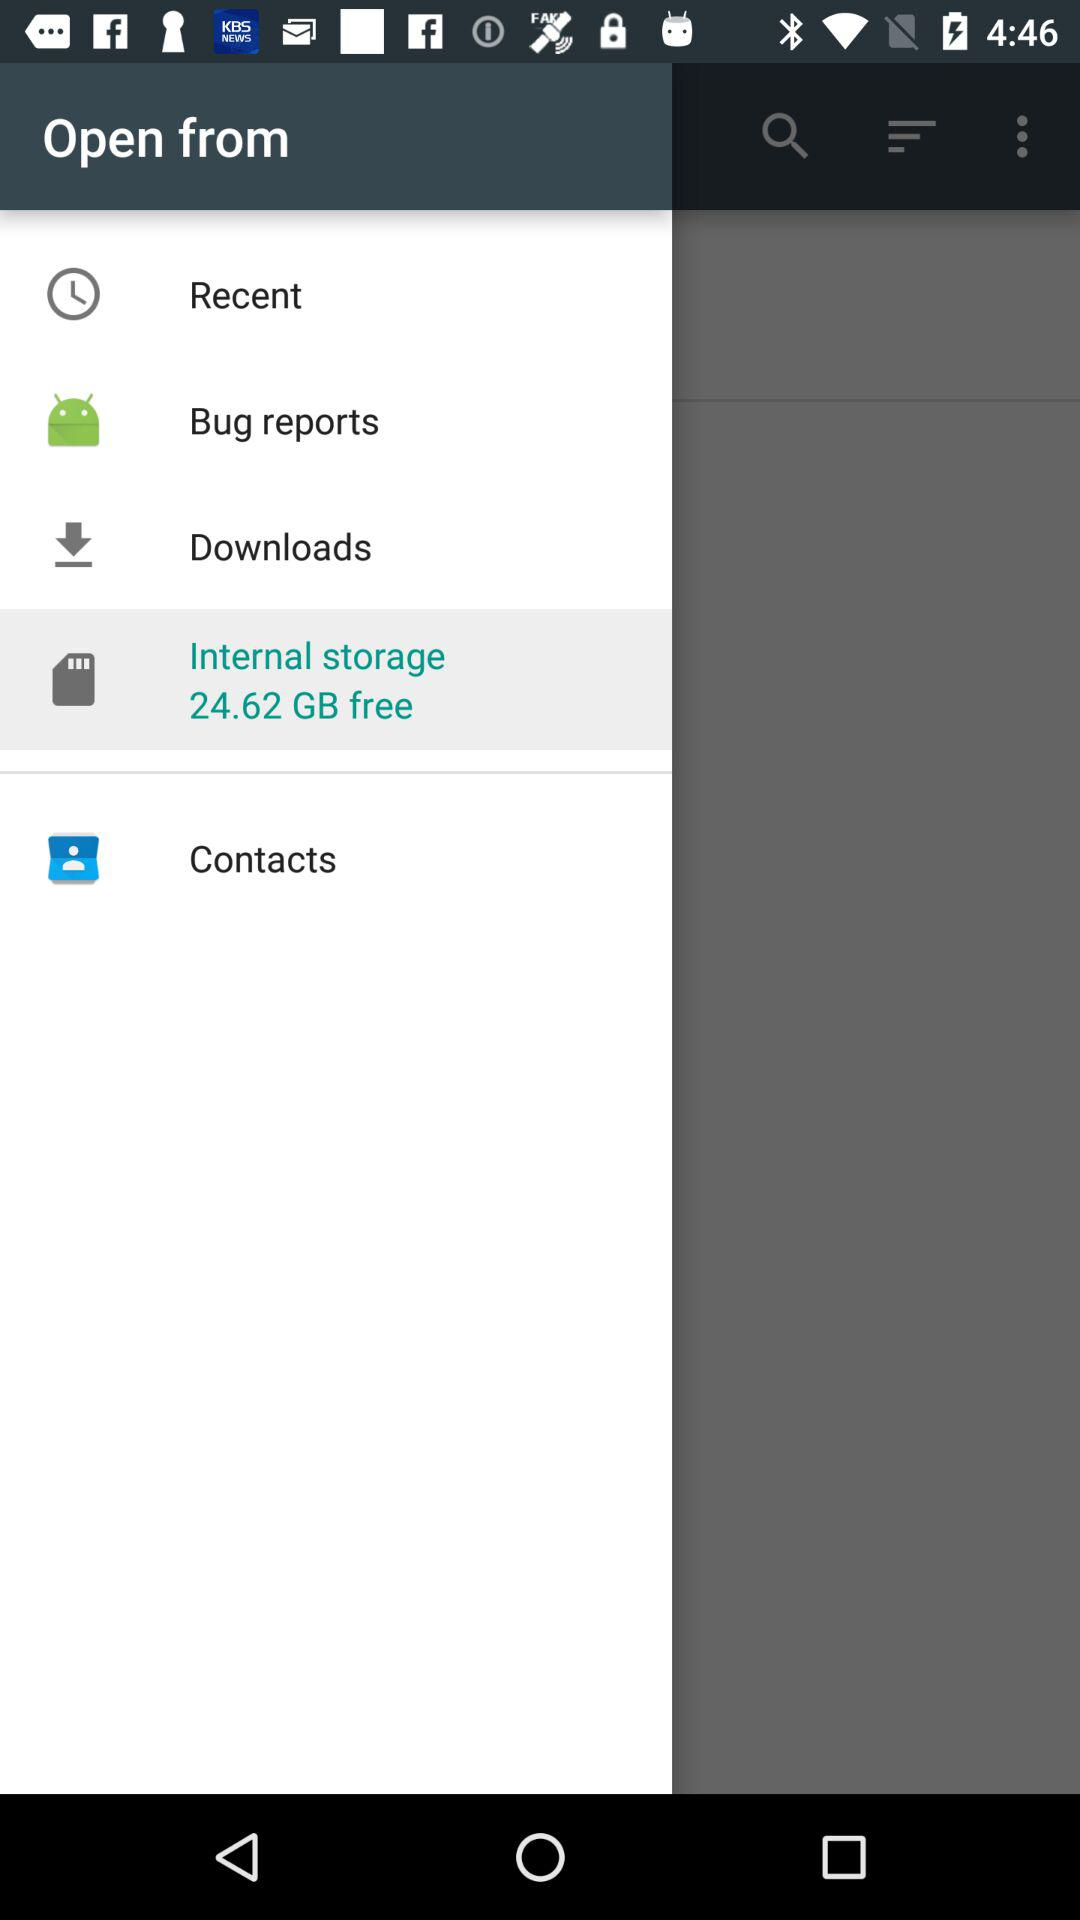What is the selected tab? The selected tab is "Internal storage". 